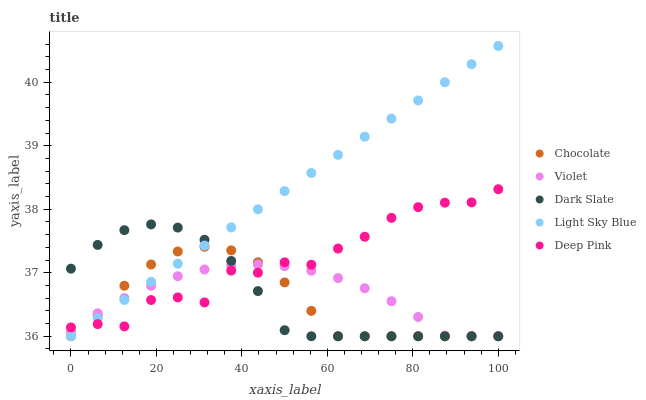Does Chocolate have the minimum area under the curve?
Answer yes or no. Yes. Does Light Sky Blue have the maximum area under the curve?
Answer yes or no. Yes. Does Violet have the minimum area under the curve?
Answer yes or no. No. Does Violet have the maximum area under the curve?
Answer yes or no. No. Is Light Sky Blue the smoothest?
Answer yes or no. Yes. Is Deep Pink the roughest?
Answer yes or no. Yes. Is Violet the smoothest?
Answer yes or no. No. Is Violet the roughest?
Answer yes or no. No. Does Dark Slate have the lowest value?
Answer yes or no. Yes. Does Deep Pink have the lowest value?
Answer yes or no. No. Does Light Sky Blue have the highest value?
Answer yes or no. Yes. Does Deep Pink have the highest value?
Answer yes or no. No. Does Dark Slate intersect Violet?
Answer yes or no. Yes. Is Dark Slate less than Violet?
Answer yes or no. No. Is Dark Slate greater than Violet?
Answer yes or no. No. 